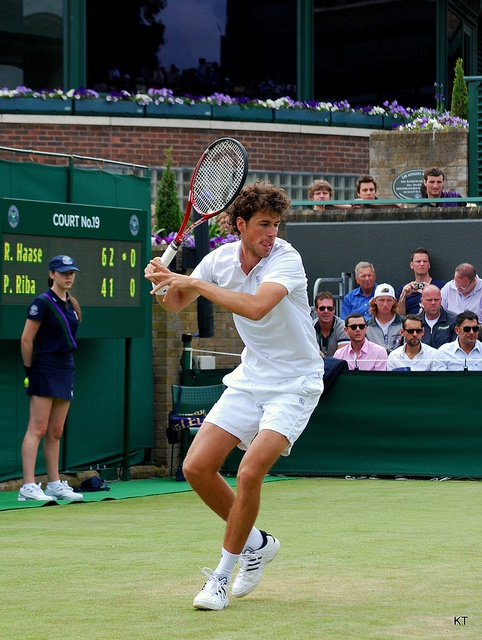Describe the objects in this image and their specific colors. I can see people in black, lavender, darkgray, maroon, and brown tones, people in black, gray, maroon, and navy tones, tennis racket in black, darkgray, gray, and lightgray tones, people in black, navy, brown, and gray tones, and people in black, lavender, and darkgray tones in this image. 